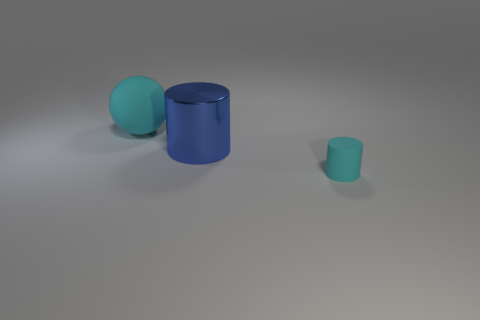Add 1 small blue matte things. How many objects exist? 4 Subtract 0 blue cubes. How many objects are left? 3 Subtract all balls. How many objects are left? 2 Subtract all large purple cylinders. Subtract all small cyan matte objects. How many objects are left? 2 Add 2 rubber balls. How many rubber balls are left? 3 Add 1 rubber balls. How many rubber balls exist? 2 